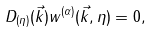Convert formula to latex. <formula><loc_0><loc_0><loc_500><loc_500>D _ { ( \eta ) } ( \vec { k } ) w ^ { ( \alpha ) } ( \vec { k } , \eta ) = 0 ,</formula> 